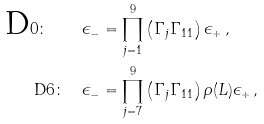<formula> <loc_0><loc_0><loc_500><loc_500>\text {D} 0 \colon \quad \epsilon _ { - } & = \prod _ { j = 1 } ^ { 9 } \left ( \Gamma _ { j } \Gamma _ { 1 1 } \right ) \epsilon _ { + } \, , \\ \text {D} 6 \colon \quad \epsilon _ { - } & = \prod _ { j = 7 } ^ { 9 } \left ( \Gamma _ { j } \Gamma _ { 1 1 } \right ) \rho ( L ) \epsilon _ { + } \, ,</formula> 